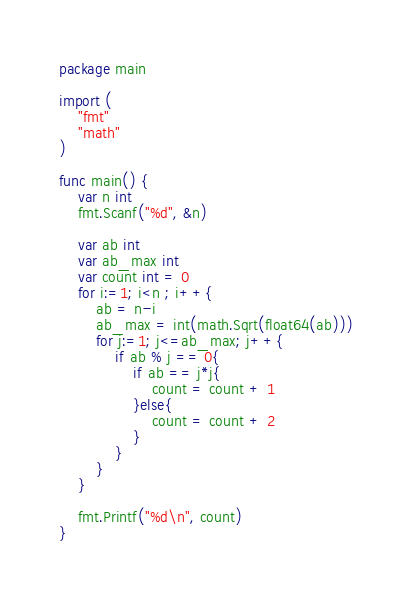<code> <loc_0><loc_0><loc_500><loc_500><_Go_>package main

import (
	"fmt"
	"math"
)

func main() {
    var n int
    fmt.Scanf("%d", &n)

	var ab int
	var ab_max int
	var count int = 0
	for i:=1; i<n ; i++{
		ab = n-i
		ab_max = int(math.Sqrt(float64(ab)))
		for j:=1; j<=ab_max; j++{
			if ab % j == 0{
				if ab == j*j{
					count = count + 1
				}else{
					count = count + 2
				}
			}
		}
	}

    fmt.Printf("%d\n", count)
}</code> 